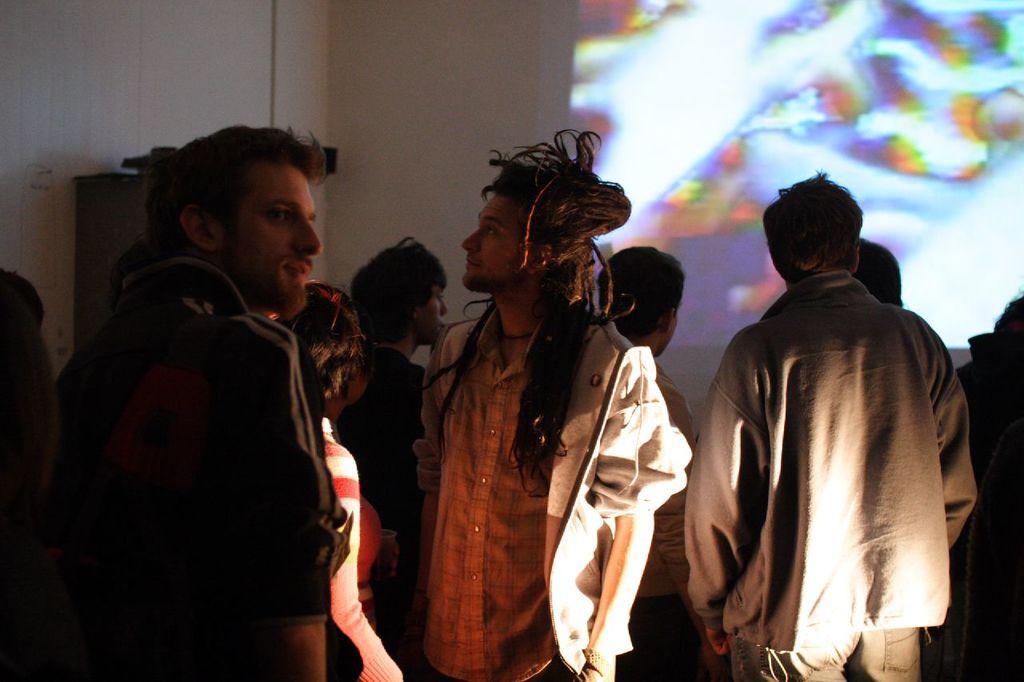Please provide a concise description of this image. In this image, we can see people standing and in the background, there is a screen on the wall and we can see an object. 